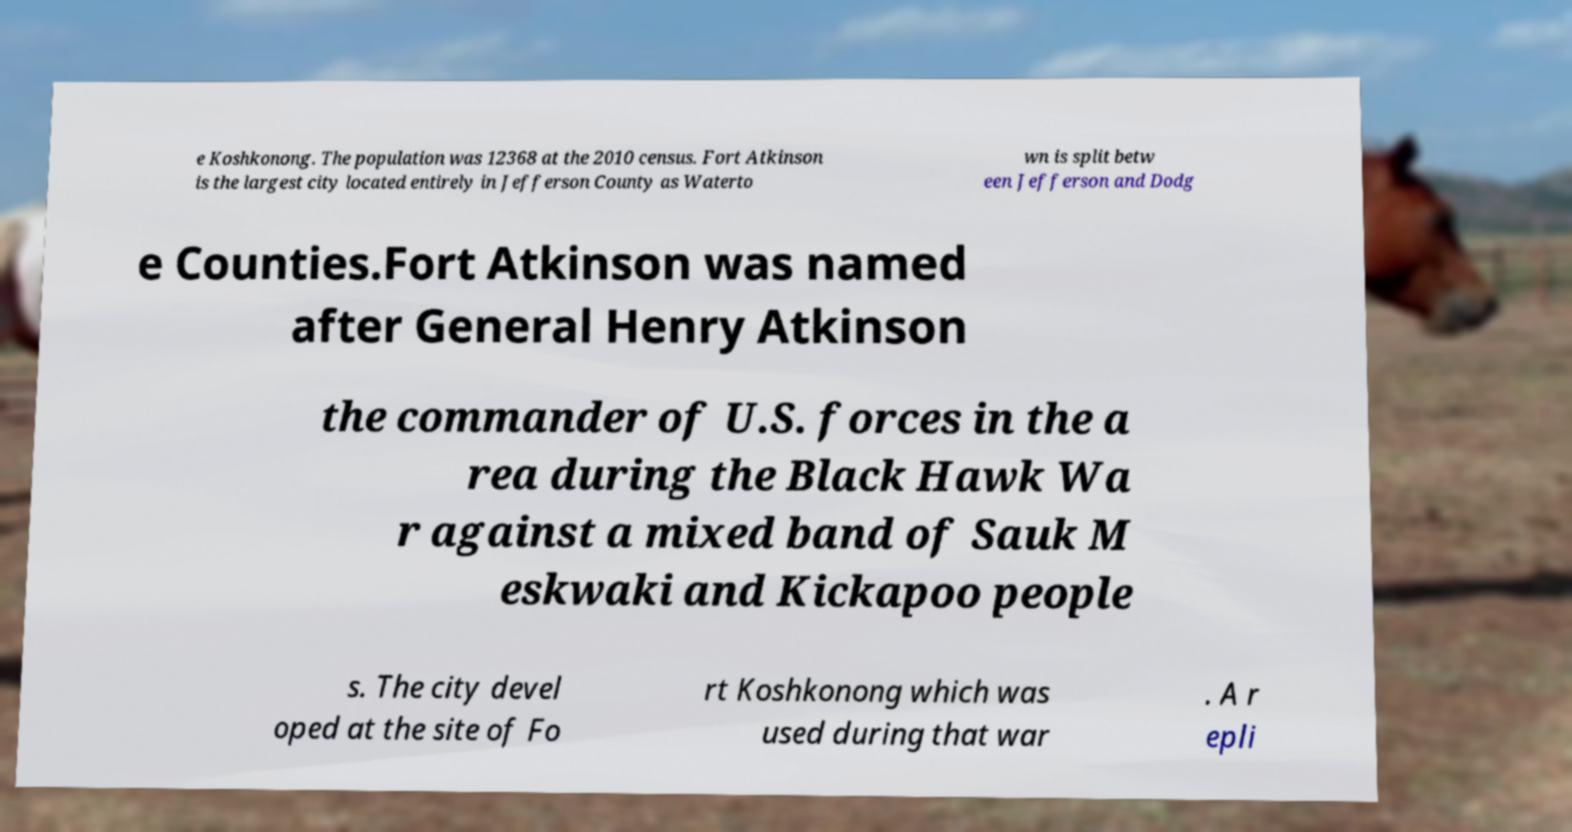Could you extract and type out the text from this image? e Koshkonong. The population was 12368 at the 2010 census. Fort Atkinson is the largest city located entirely in Jefferson County as Waterto wn is split betw een Jefferson and Dodg e Counties.Fort Atkinson was named after General Henry Atkinson the commander of U.S. forces in the a rea during the Black Hawk Wa r against a mixed band of Sauk M eskwaki and Kickapoo people s. The city devel oped at the site of Fo rt Koshkonong which was used during that war . A r epli 